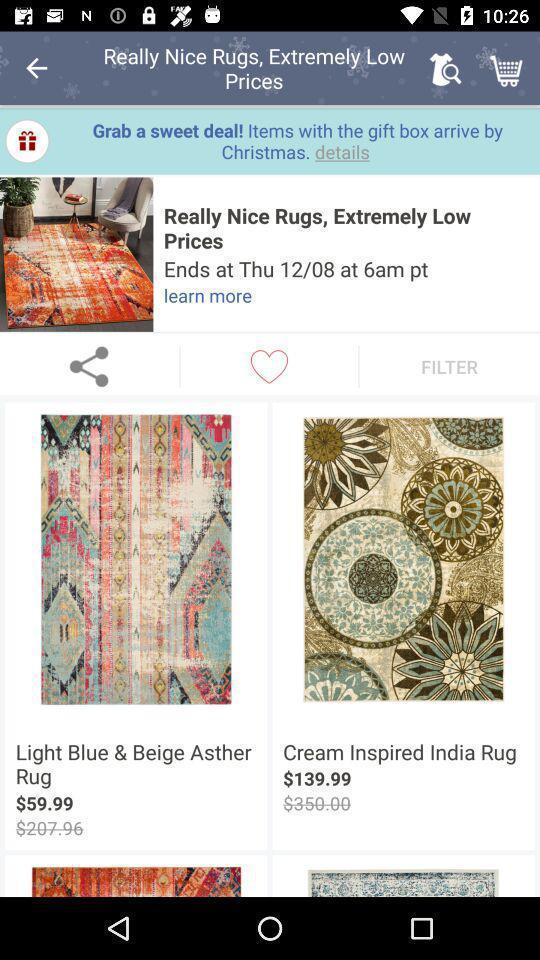Describe the visual elements of this screenshot. Screen page of a shopping application. 